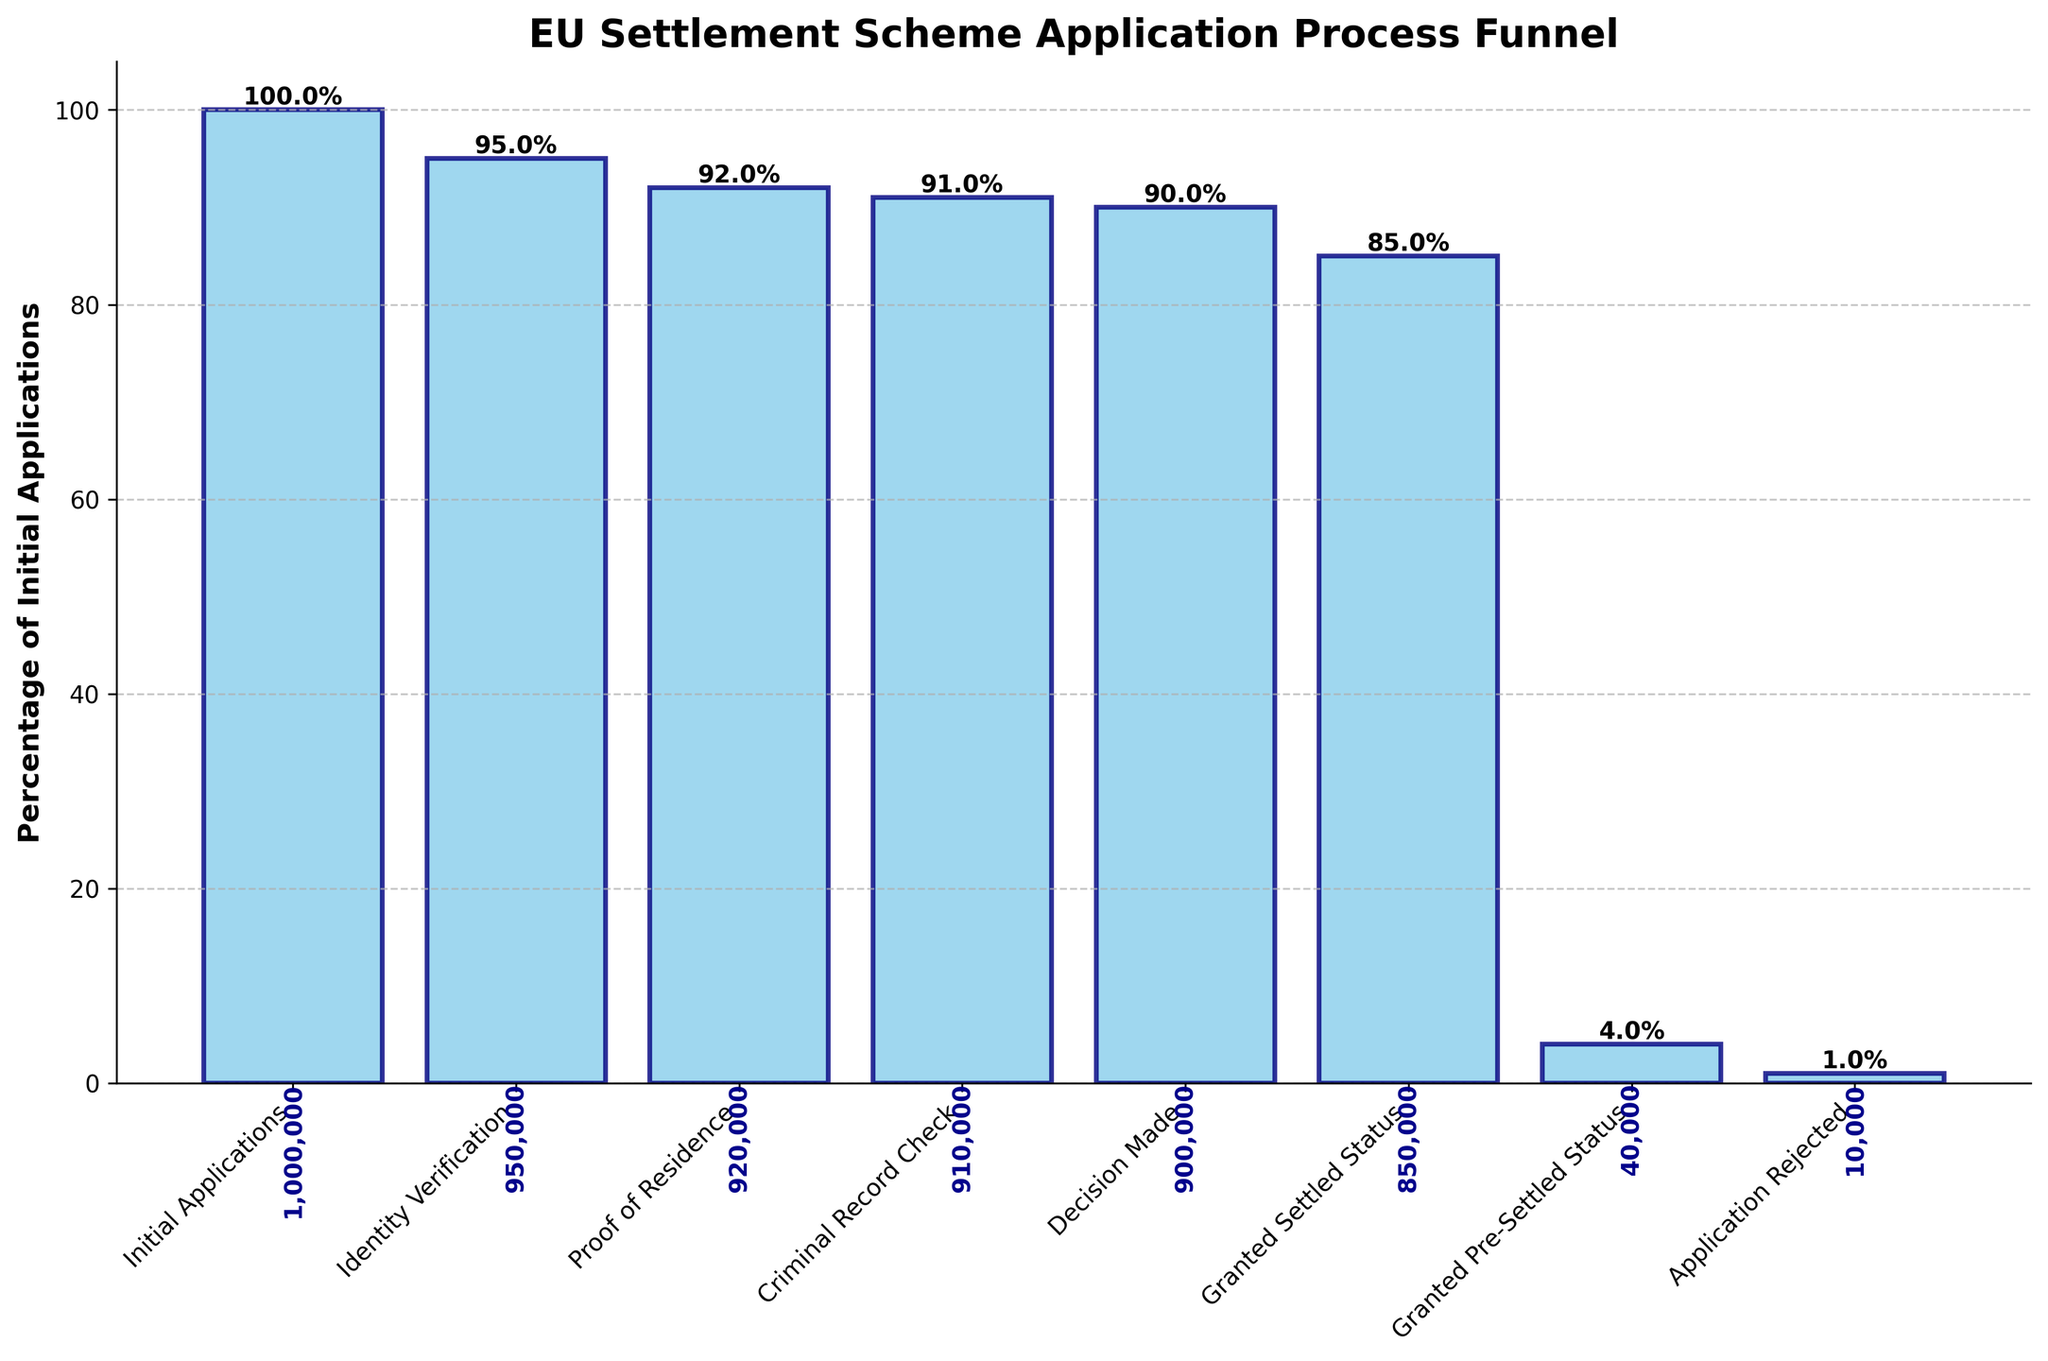Is there an increase or decrease in the number of applicants from the Identity Verification step to the Proof of Residence step? The number of applicants in the Identity Verification step is 950,000, and it decreases to 920,000 in the Proof of Residence step. The decrease is calculated by subtracting the latter from the former: 950,000 - 920,000 = 30,000.
Answer: Decrease What percentage of applicants were granted Settled Status relative to the initial applications? The number of applicants granted Settled Status is 850,000. The initial applications were 1,000,000. To find this percentage, you divide 850,000 by 1,000,000 and multiply by 100: (850,000 / 1,000,000) * 100 = 85%.
Answer: 85% What is the title of the figure? The title of the figure is prominently displayed above the chart and reads "EU Settlement Scheme Application Process Funnel."
Answer: EU Settlement Scheme Application Process Funnel How many steps involve a reduction of 10,000 or more applicants? By examining each step:
- Initial Applications to Identity Verification: 1,000,000 to 950,000 (50,000)
- Identity Verification to Proof of Residence: 950,000 to 920,000 (30,000)
- Proof of Residence to Criminal Record Check: 920,000 to 910,000 (10,000)
- Criminal Record Check to Decision Made: 910,000 to 900,000 (10,000)
- Decision Made to Granted Settled Status: 900,000 to 850,000 (50,000)
There are 4 steps with reductions of 10,000 or more.
Answer: 4 What is the difference between the number of applicants who were granted Pre-Settled Status and those whose applications were rejected? The number of applicants granted Pre-Settled Status is 40,000, and the number rejected is 10,000. The difference is 40,000 - 10,000 = 30,000.
Answer: 30,000 Which step has the least number of applicants? The step with the least number of applicants is "Application Rejected" with 10,000 applicants. This can be determined by comparing all the values in the chart.
Answer: Application Rejected How many more applicants were granted Settled Status compared to those granted Pre-Settled Status? The number of applicants granted Settled Status is 850,000, whereas those granted Pre-Settled Status is 40,000. The difference between them is calculated by subtracting: 850,000 - 40,000 = 810,000.
Answer: 810,000 What is the overall approval rate (both Settled Status and Pre-Settled Status) as a percentage of initial applications? The combined number of applicants who were granted Settled Status or Pre-Settled Status is 850,000 + 40,000 = 890,000. To find the approval rate relative to the initial applications of 1,000,000, divide 890,000 by 1,000,000 and multiply by 100: (890,000 / 1,000,000) * 100 = 89%.
Answer: 89% 